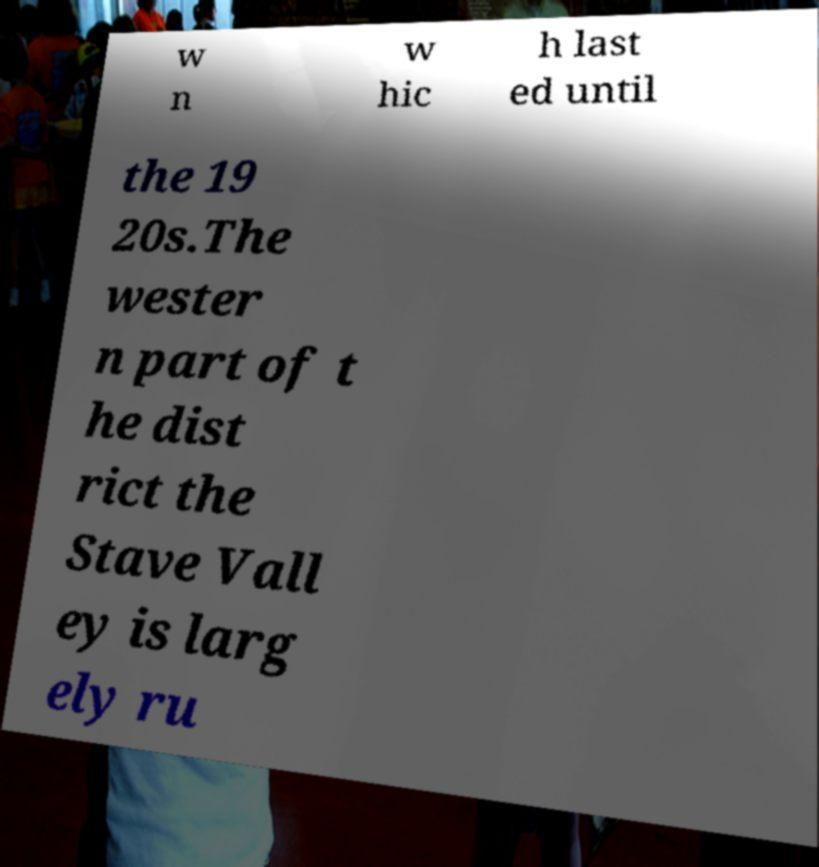Please identify and transcribe the text found in this image. w n w hic h last ed until the 19 20s.The wester n part of t he dist rict the Stave Vall ey is larg ely ru 